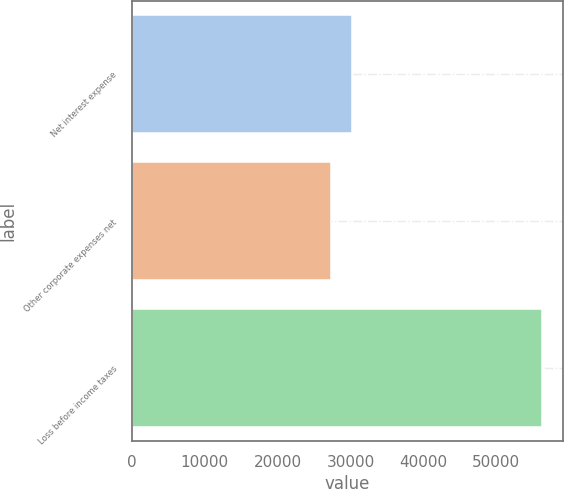Convert chart. <chart><loc_0><loc_0><loc_500><loc_500><bar_chart><fcel>Net interest expense<fcel>Other corporate expenses net<fcel>Loss before income taxes<nl><fcel>30207.7<fcel>27309<fcel>56296<nl></chart> 